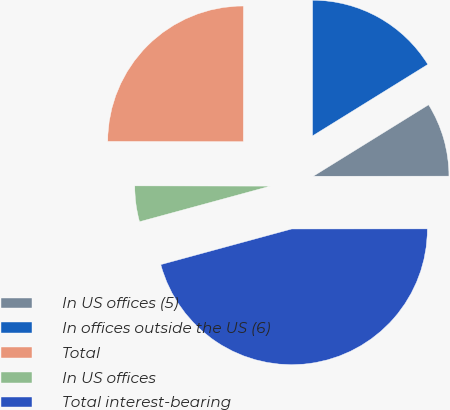Convert chart to OTSL. <chart><loc_0><loc_0><loc_500><loc_500><pie_chart><fcel>In US offices (5)<fcel>In offices outside the US (6)<fcel>Total<fcel>In US offices<fcel>Total interest-bearing<nl><fcel>8.82%<fcel>16.16%<fcel>24.98%<fcel>4.26%<fcel>45.78%<nl></chart> 